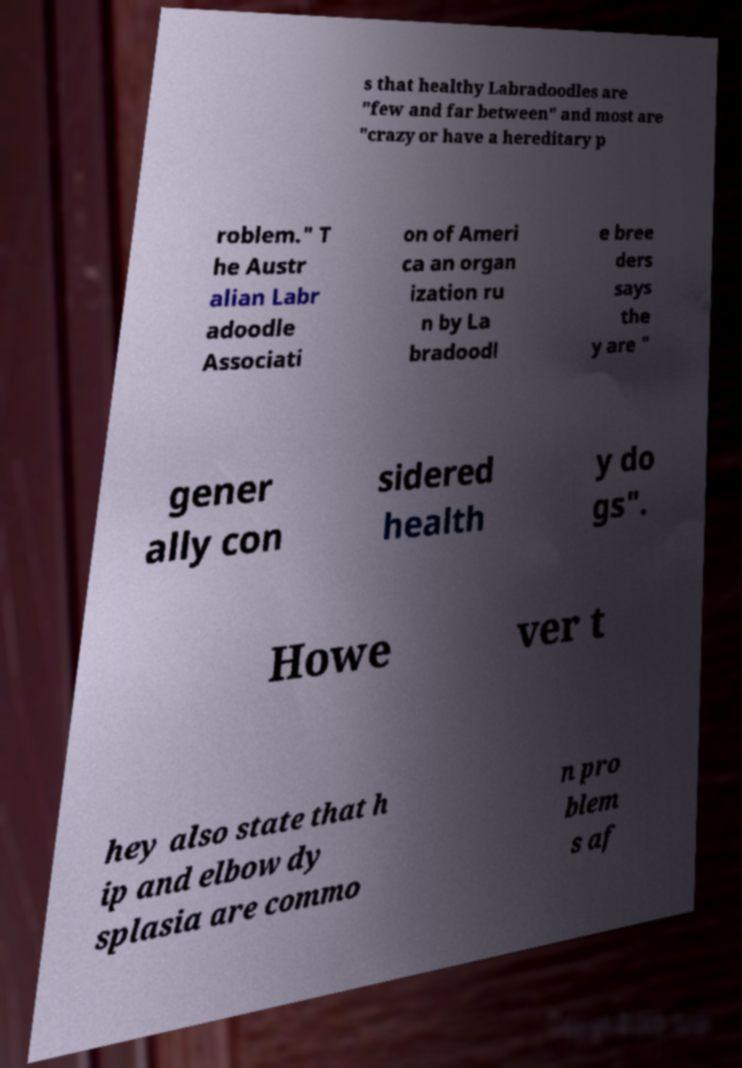Could you extract and type out the text from this image? s that healthy Labradoodles are "few and far between" and most are "crazy or have a hereditary p roblem." T he Austr alian Labr adoodle Associati on of Ameri ca an organ ization ru n by La bradoodl e bree ders says the y are " gener ally con sidered health y do gs". Howe ver t hey also state that h ip and elbow dy splasia are commo n pro blem s af 